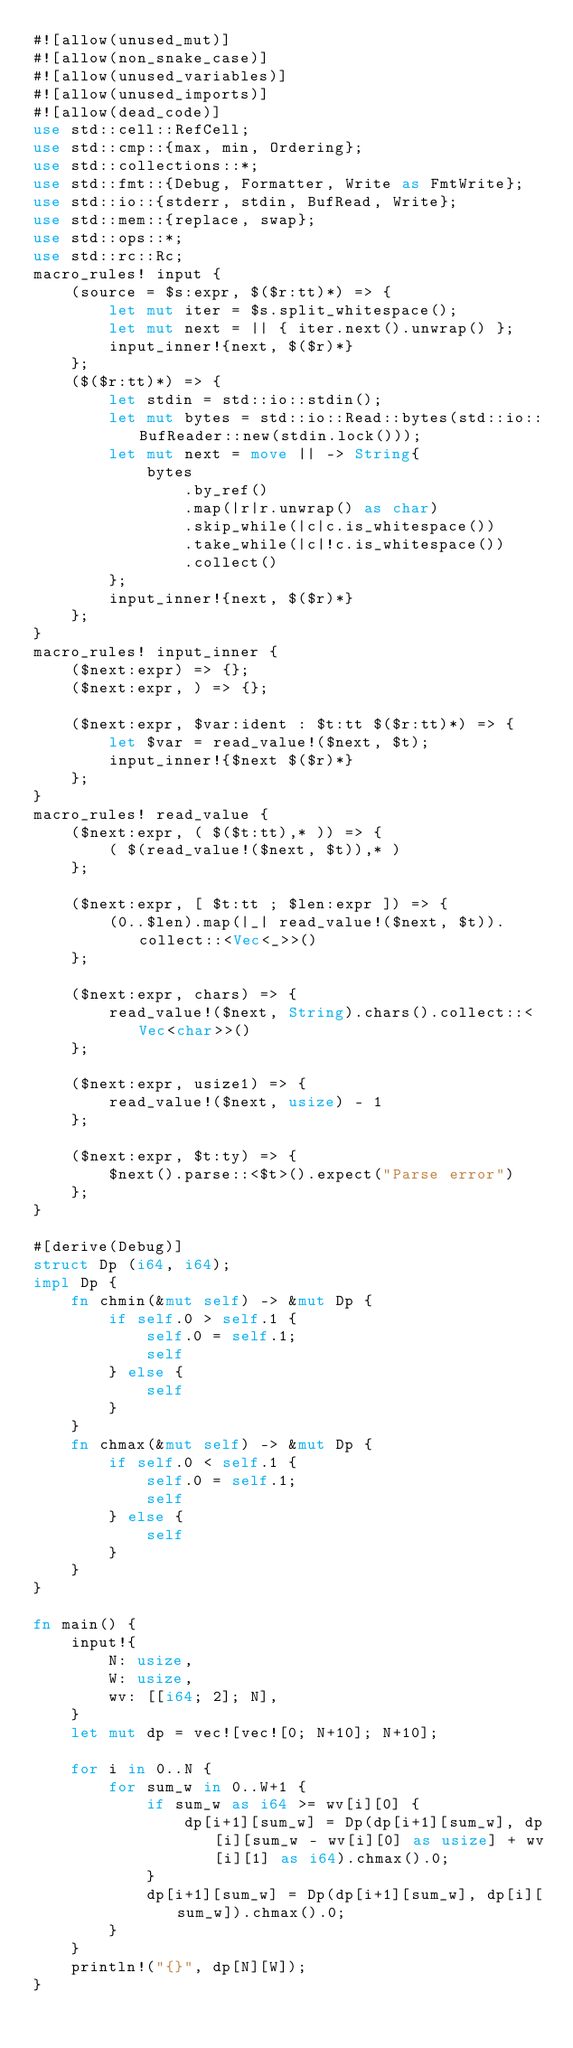<code> <loc_0><loc_0><loc_500><loc_500><_Rust_>#![allow(unused_mut)]
#![allow(non_snake_case)]
#![allow(unused_variables)]
#![allow(unused_imports)]
#![allow(dead_code)]
use std::cell::RefCell;
use std::cmp::{max, min, Ordering};
use std::collections::*;
use std::fmt::{Debug, Formatter, Write as FmtWrite};
use std::io::{stderr, stdin, BufRead, Write};
use std::mem::{replace, swap};
use std::ops::*;
use std::rc::Rc;
macro_rules! input {
    (source = $s:expr, $($r:tt)*) => {
        let mut iter = $s.split_whitespace();
        let mut next = || { iter.next().unwrap() };
        input_inner!{next, $($r)*}
    };
    ($($r:tt)*) => {
        let stdin = std::io::stdin();
        let mut bytes = std::io::Read::bytes(std::io::BufReader::new(stdin.lock()));
        let mut next = move || -> String{
            bytes
                .by_ref()
                .map(|r|r.unwrap() as char)
                .skip_while(|c|c.is_whitespace())
                .take_while(|c|!c.is_whitespace())
                .collect()
        };
        input_inner!{next, $($r)*}
    };
}
macro_rules! input_inner {
    ($next:expr) => {};
    ($next:expr, ) => {};

    ($next:expr, $var:ident : $t:tt $($r:tt)*) => {
        let $var = read_value!($next, $t);
        input_inner!{$next $($r)*}
    };
}
macro_rules! read_value {
    ($next:expr, ( $($t:tt),* )) => {
        ( $(read_value!($next, $t)),* )
    };

    ($next:expr, [ $t:tt ; $len:expr ]) => {
        (0..$len).map(|_| read_value!($next, $t)).collect::<Vec<_>>()
    };

    ($next:expr, chars) => {
        read_value!($next, String).chars().collect::<Vec<char>>()
    };

    ($next:expr, usize1) => {
        read_value!($next, usize) - 1
    };

    ($next:expr, $t:ty) => {
        $next().parse::<$t>().expect("Parse error")
    };
}

#[derive(Debug)]
struct Dp (i64, i64);
impl Dp {
    fn chmin(&mut self) -> &mut Dp {
        if self.0 > self.1 {
            self.0 = self.1;
            self
        } else {
            self
        }
    }
    fn chmax(&mut self) -> &mut Dp {
        if self.0 < self.1 {
            self.0 = self.1;
            self
        } else {
            self
        }
    }
}

fn main() {
    input!{
        N: usize,
        W: usize,
        wv: [[i64; 2]; N],
    }
    let mut dp = vec![vec![0; N+10]; N+10];

    for i in 0..N {
        for sum_w in 0..W+1 {
            if sum_w as i64 >= wv[i][0] {
                dp[i+1][sum_w] = Dp(dp[i+1][sum_w], dp[i][sum_w - wv[i][0] as usize] + wv[i][1] as i64).chmax().0;
            }
            dp[i+1][sum_w] = Dp(dp[i+1][sum_w], dp[i][sum_w]).chmax().0;
        }
    }
    println!("{}", dp[N][W]);
}

</code> 